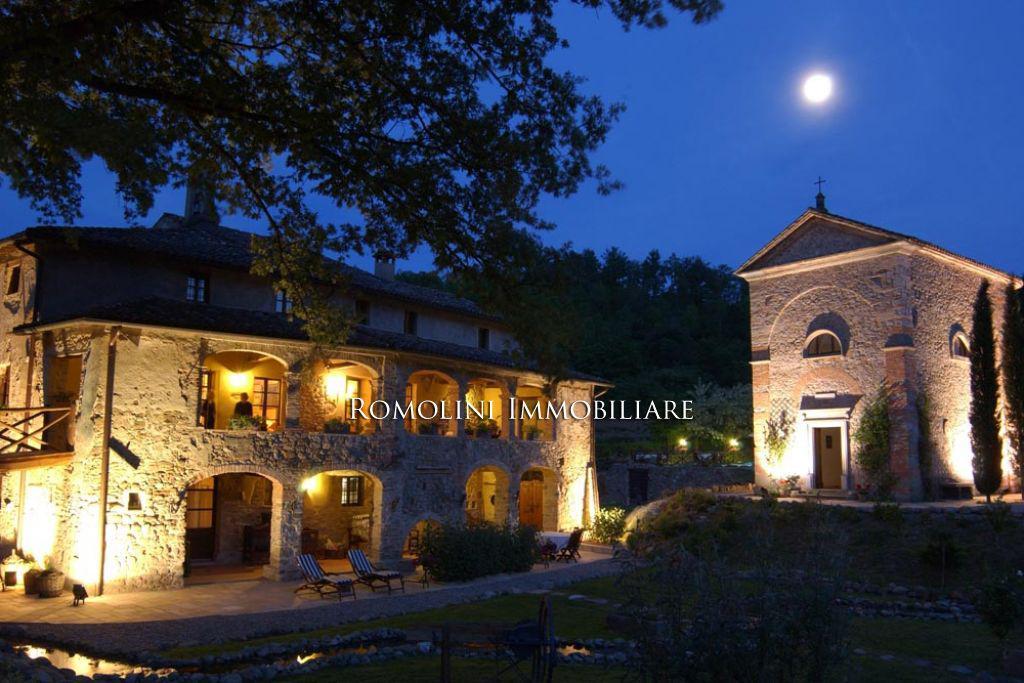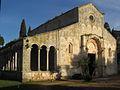The first image is the image on the left, the second image is the image on the right. Examine the images to the left and right. Is the description "There is a gazebo in one of the images." accurate? Answer yes or no. No. 